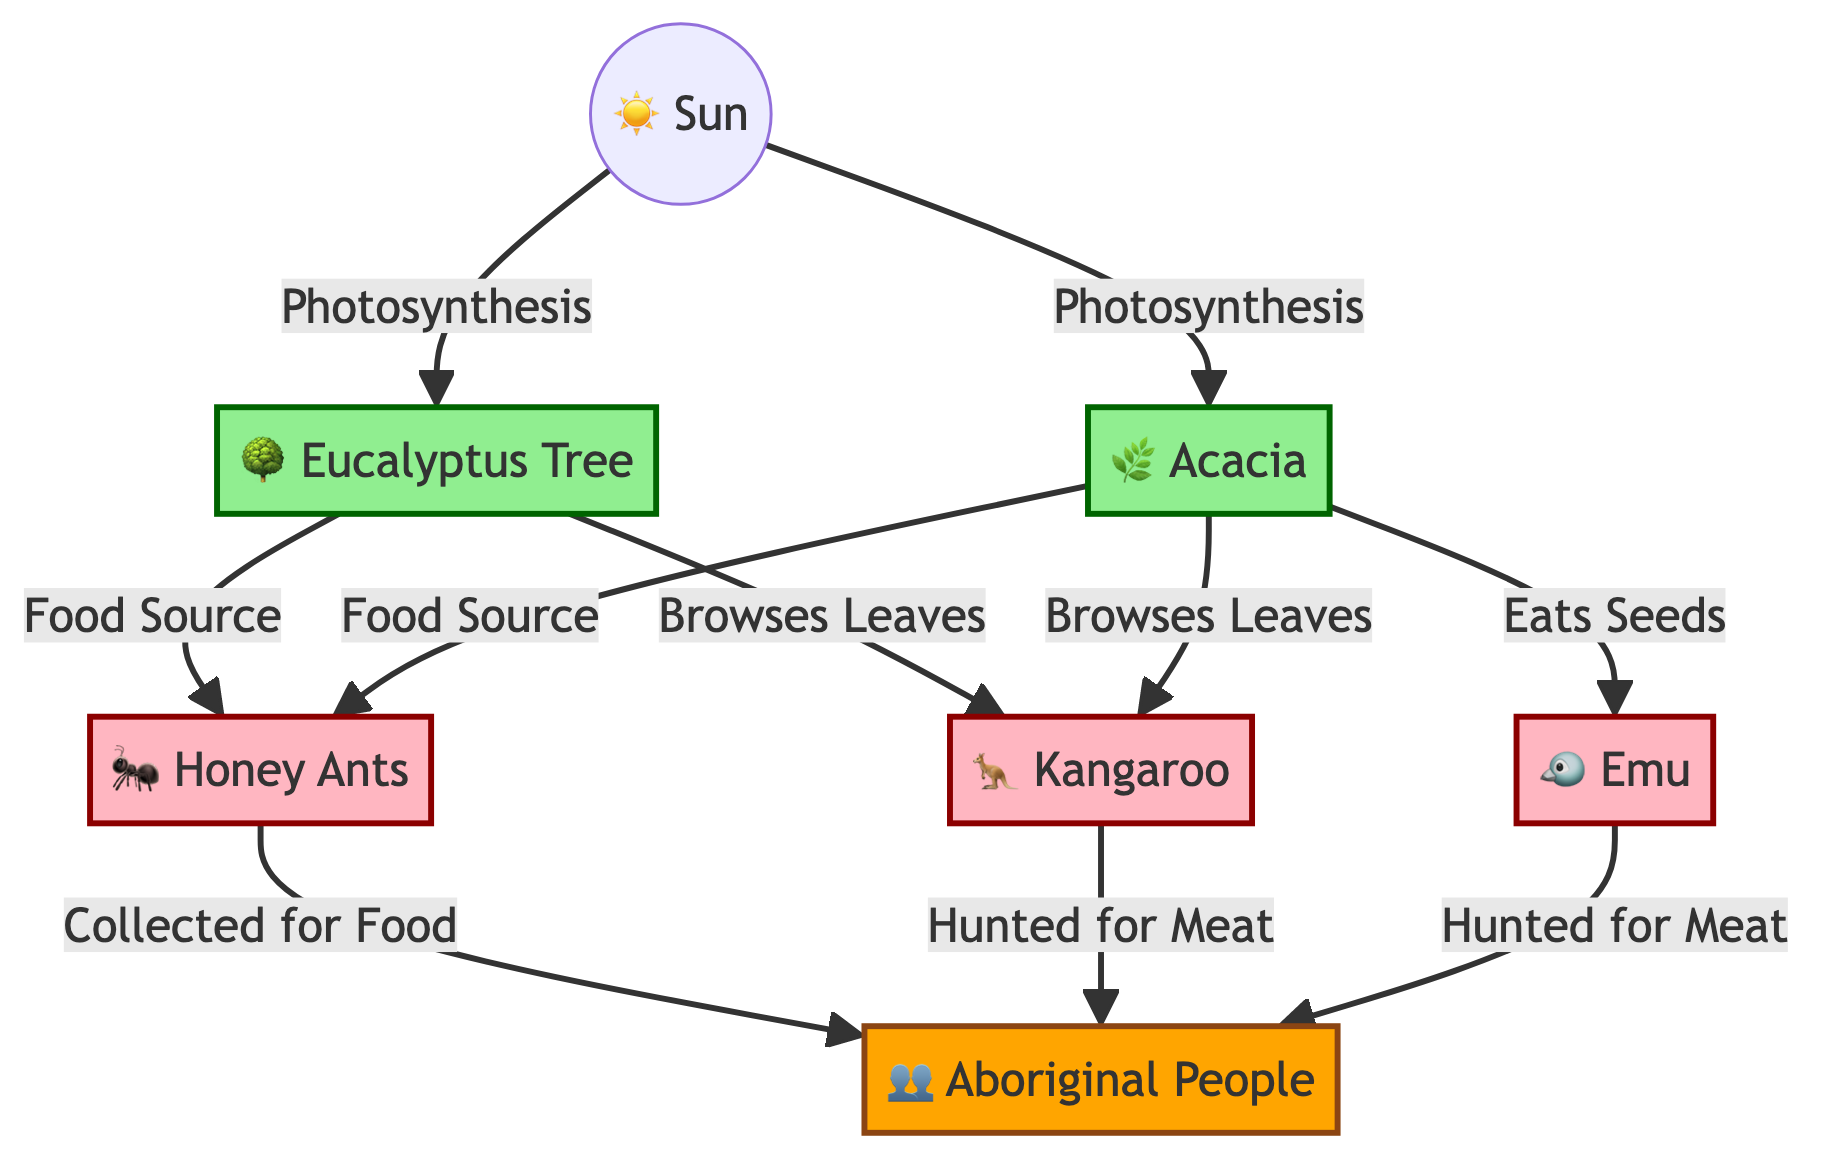What are the producers in the food chain? The producers are the organisms that create food through photosynthesis, which in this diagram are the Eucalyptus Tree and Acacia.
Answer: Eucalyptus Tree, Acacia How many consumers are there in the food chain? The consumers are the organisms that consume the producers or other consumers. In this diagram, Honey Ants, Kangaroo, and Emu are consumers, making a total of three consumers.
Answer: 3 What do Honey Ants collect for food? According to the diagram, Honey Ants are collected for food by Aboriginal People, which shows that they are a part of the food chain.
Answer: Collected for Food Who hunts Kangaroo for meat? The diagram clearly indicates that Aboriginal People hunt Kangaroo for meat, establishing a direct relationship between them in the food chain.
Answer: Aboriginal People Which plant is eaten by Emu? The diagram indicates that Emu eats seeds from the Acacia plant, highlighting the plant-animal interaction.
Answer: Acacia What role do Aboriginal People serve in the food chain? In the diagram, Aboriginal People are depicted as the apex of the food chain, indicating their position at the top as hunters of various animals.
Answer: Apex How does sunlight contribute to the food chain? Sunlight is essential for photosynthesis, which is the process that allows the Eucalyptus Tree and Acacia to produce food, starting the food chain process.
Answer: Photosynthesis Which animal eats leaves from both Eucalyptus Tree and Acacia? According to the diagram, Kangaroo browses leaves from both Eucalyptus Tree and Acacia, linking these plants to the Kangaroo in the food chain.
Answer: Kangaroo What is the relationship between Acacia and Honey Ants? The diagram shows a direct relationship where Acacia serves as a food source for Honey Ants, which is a classic producer-consumer interaction.
Answer: Food Source 